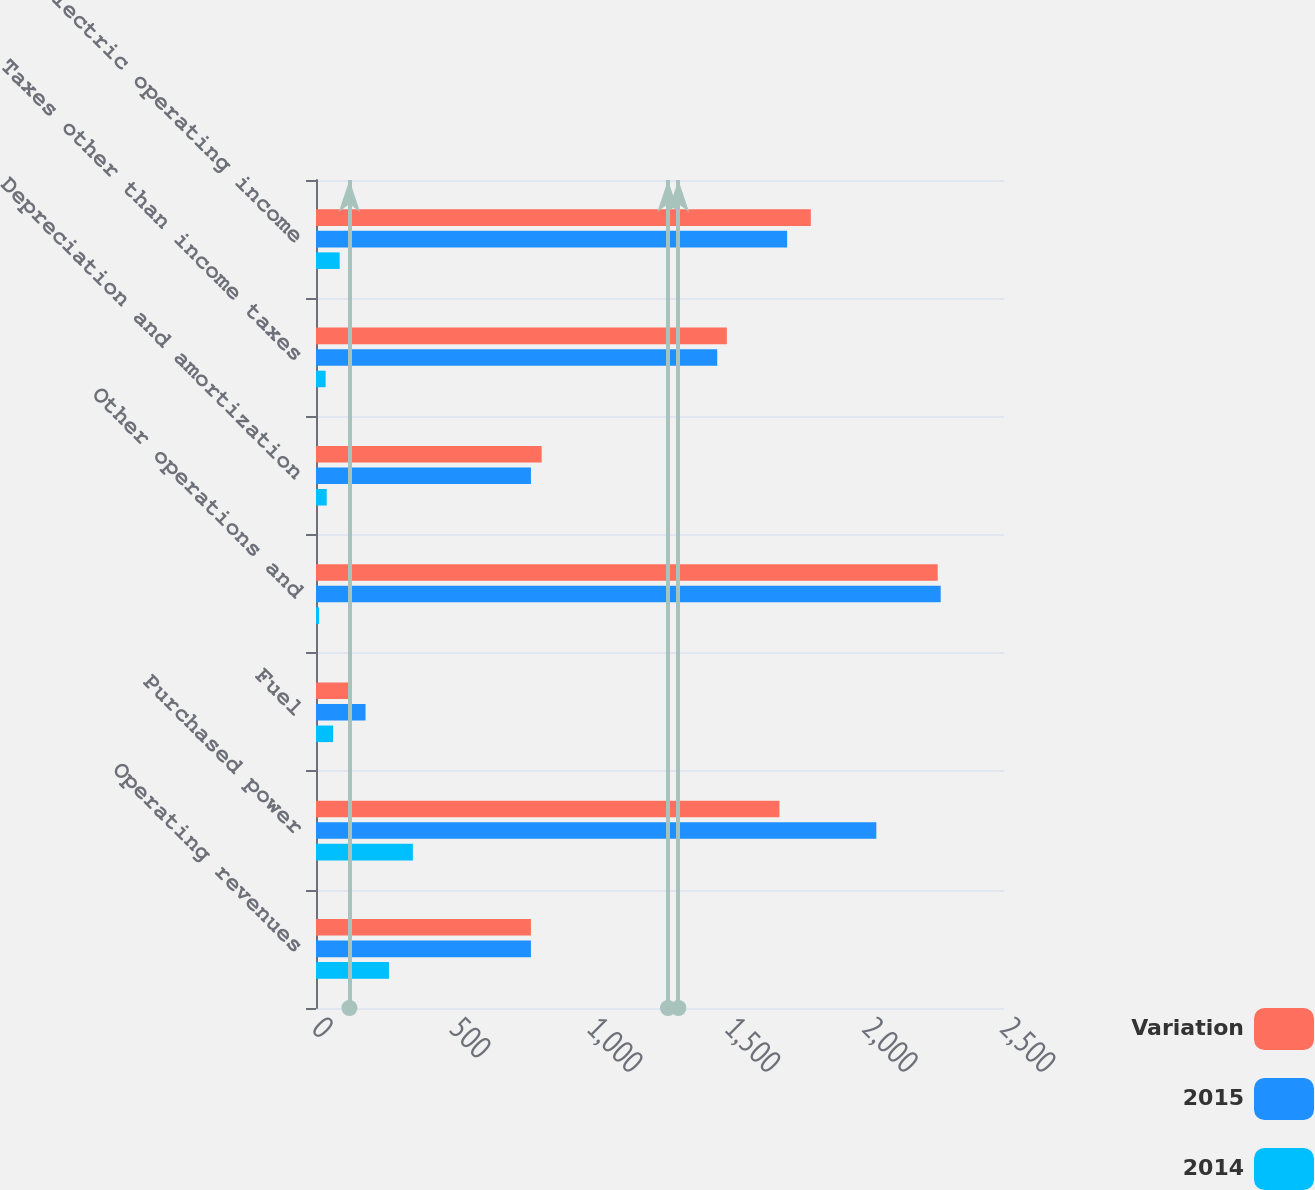<chart> <loc_0><loc_0><loc_500><loc_500><stacked_bar_chart><ecel><fcel>Operating revenues<fcel>Purchased power<fcel>Fuel<fcel>Other operations and<fcel>Depreciation and amortization<fcel>Taxes other than income taxes<fcel>Electric operating income<nl><fcel>Variation<fcel>781<fcel>1684<fcel>118<fcel>2259<fcel>820<fcel>1493<fcel>1798<nl><fcel>2015<fcel>781<fcel>2036<fcel>180<fcel>2270<fcel>781<fcel>1458<fcel>1712<nl><fcel>2014<fcel>265<fcel>352<fcel>62<fcel>11<fcel>39<fcel>35<fcel>86<nl></chart> 